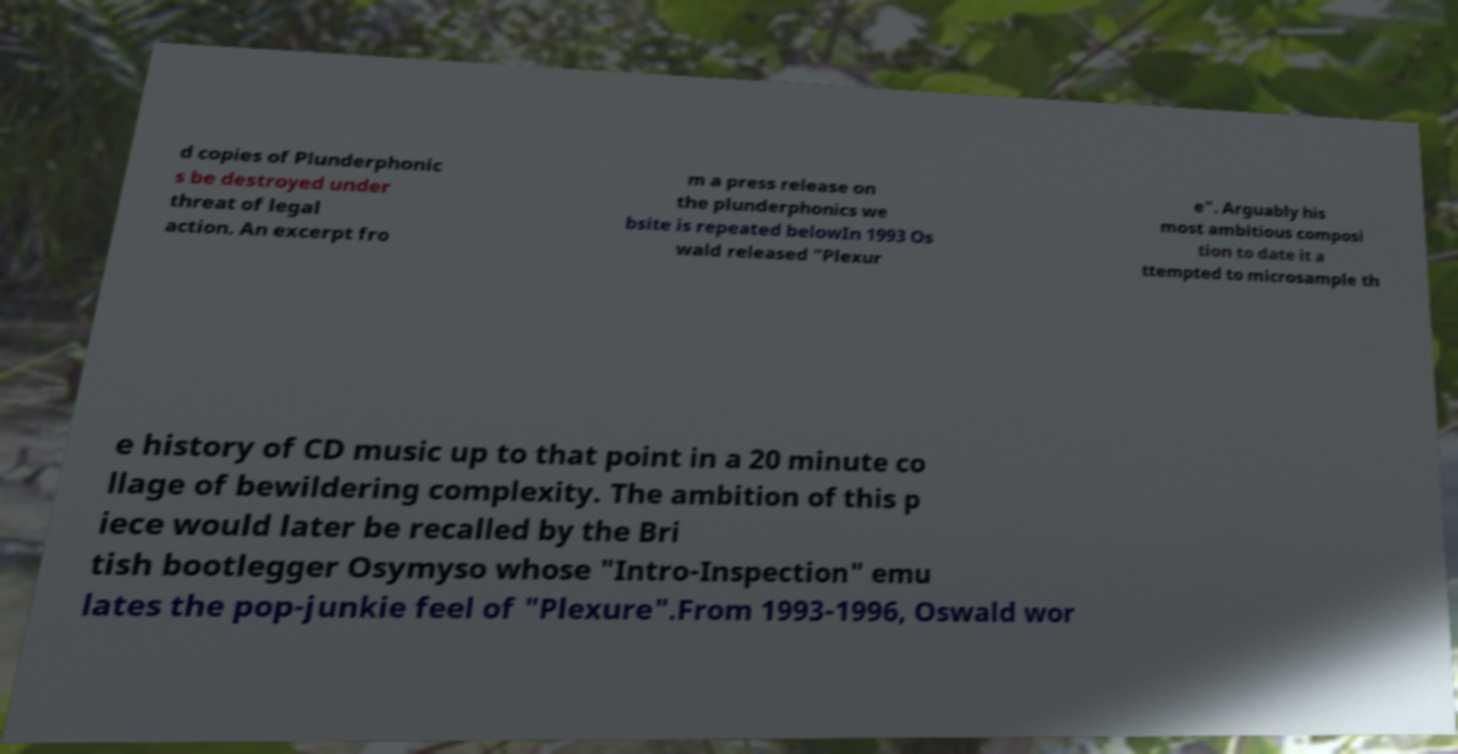Can you accurately transcribe the text from the provided image for me? d copies of Plunderphonic s be destroyed under threat of legal action. An excerpt fro m a press release on the plunderphonics we bsite is repeated belowIn 1993 Os wald released "Plexur e". Arguably his most ambitious composi tion to date it a ttempted to microsample th e history of CD music up to that point in a 20 minute co llage of bewildering complexity. The ambition of this p iece would later be recalled by the Bri tish bootlegger Osymyso whose "Intro-Inspection" emu lates the pop-junkie feel of "Plexure".From 1993-1996, Oswald wor 